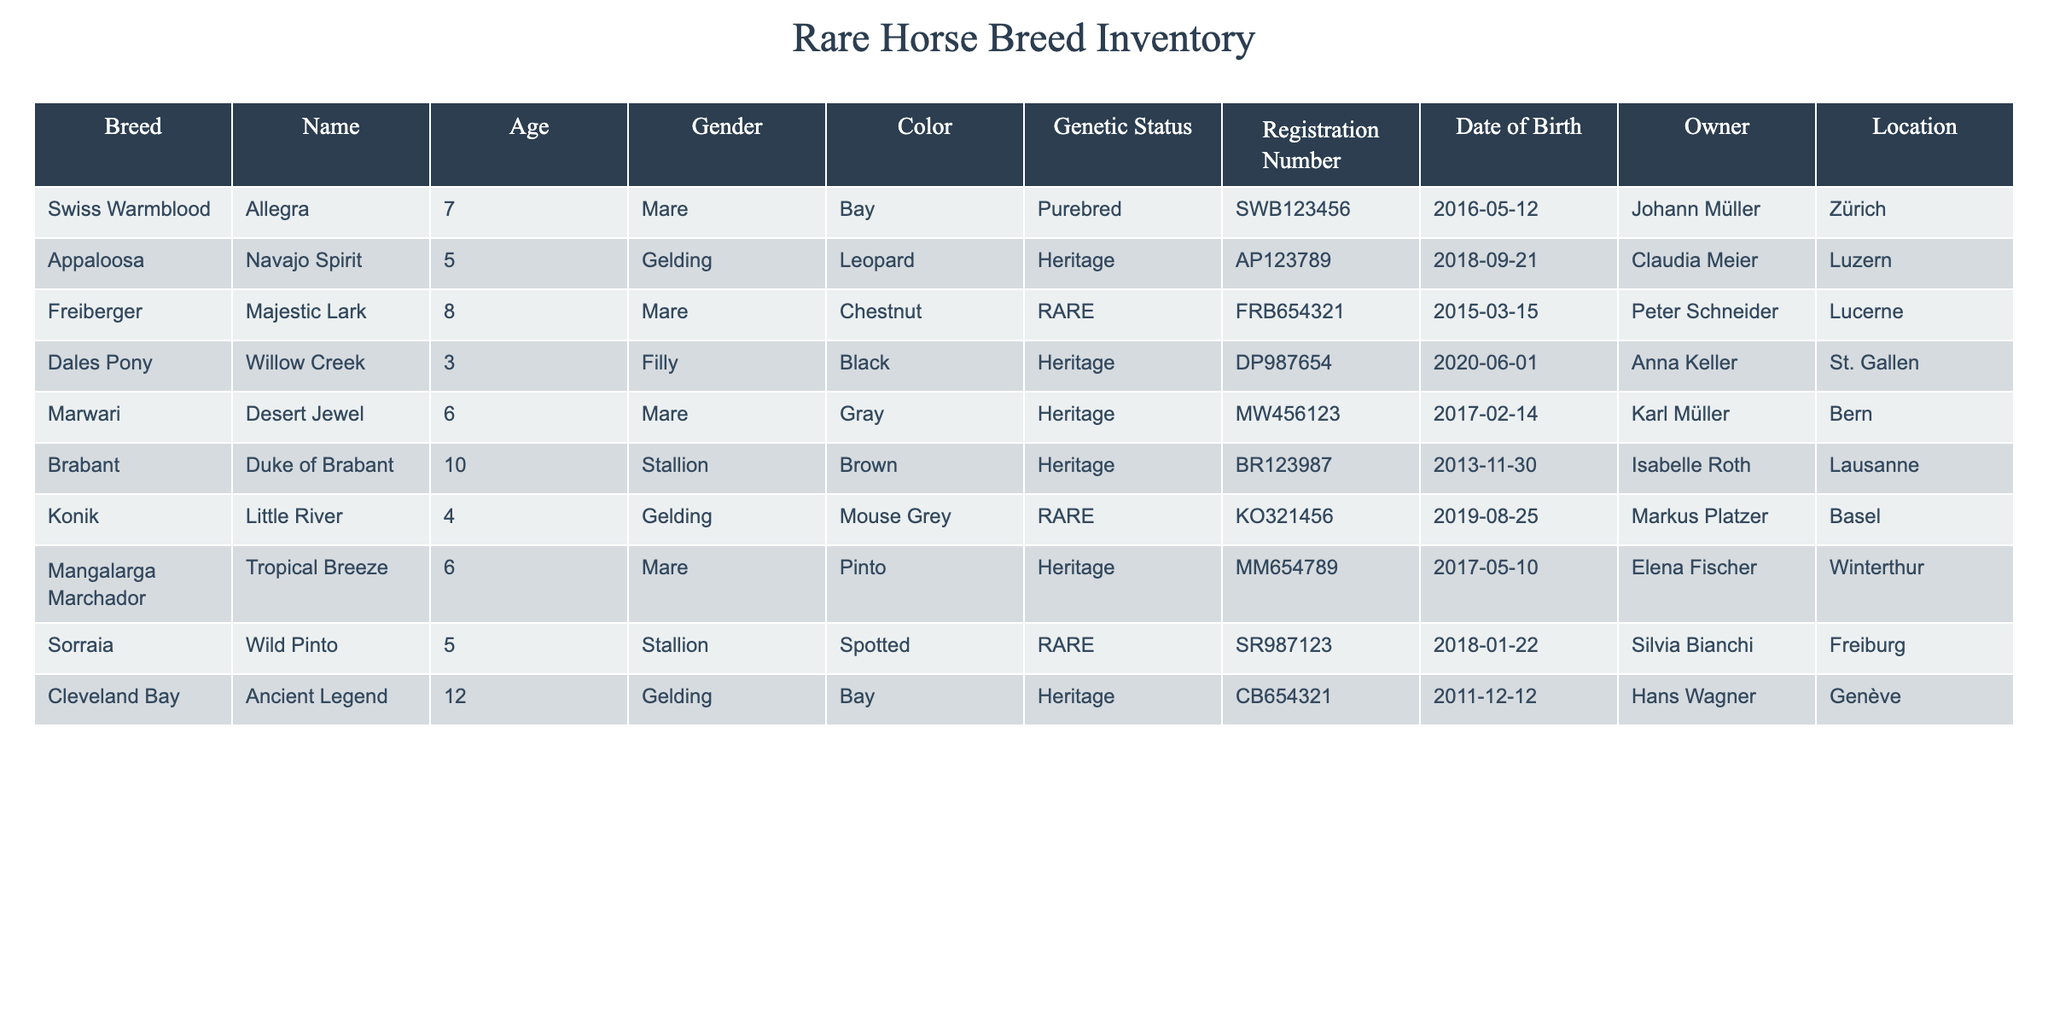What is the age of the Freiberger horse named Majestic Lark? The data for the horse breed Freiberger shows that Majestic Lark is 8 years old as stated in the 'Age' column.
Answer: 8 How many horses in the inventory are considered rare? The 'Genetic Status' column indicates that there are 3 horses marked as RARE: Freiberger (Majestic Lark), Konik (Little River), and Sorraia (Wild Pinto).
Answer: 3 Is there a stallion in the breeding stock? By examining the 'Gender' column, we can see that Duke of Brabant and Wild Pinto are both identified as stallions, confirming there are stallions present.
Answer: Yes Which horse has the earliest date of birth? Scanning the 'Date of Birth' column, Ancient Legend (born on 2011-12-12) is the earliest date when compared to others.
Answer: Ancient Legend What is the average age of the horses listed as Heritage? The ages of the horses identified as Heritage are 5 (Navajo Spirit) + 3 (Willow Creek) + 6 (Desert Jewel) + 6 (Tropical Breeze) + 12 (Ancient Legend), which gives a sum of 32. There are 5 of them, so the average is 32/5 = 6.4.
Answer: 6.4 How many owners are from the city of Zürich? From the 'Location' column, only Johann Müller owns a horse in Zürich (Allegra), resulting in 1 owner from that specific city.
Answer: 1 Which mare is brown and what is its age? Looking through the table, Duchess of Brabant is the only mare that has the color brown, and its age is 10 years old as noted in the 'Age' column.
Answer: 10 Are there any mares that are categorized as RARE? By looking at the 'Genetic Status' column among mares, it is evident that only Majestic Lark is marked as RARE, which answers the question affirmatively.
Answer: Yes What is the average age of the horses that are both geldings and considered Heritage? The geldings that are Heritage are Navajo Spirit (5 years old) and Cleveland Bay (12 years old), giving a sum of 17 and an average age of 17/2 = 8.5.
Answer: 8.5 